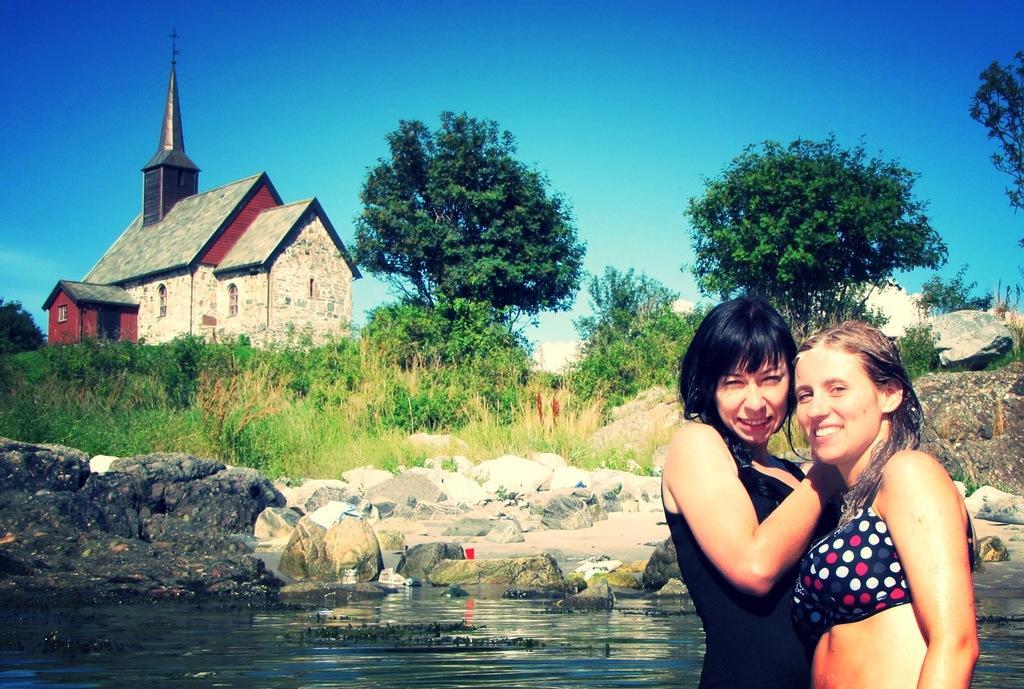Describe this image in one or two sentences. In this image we can see two ladies smiling. In the back there is water. Also there are rocks. In the background there are plants and trees. And there is a building with windows. And there is sky. 